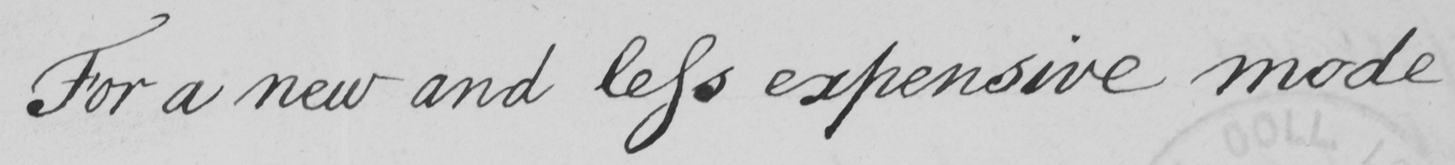Can you read and transcribe this handwriting? For a new and less expensive mode 